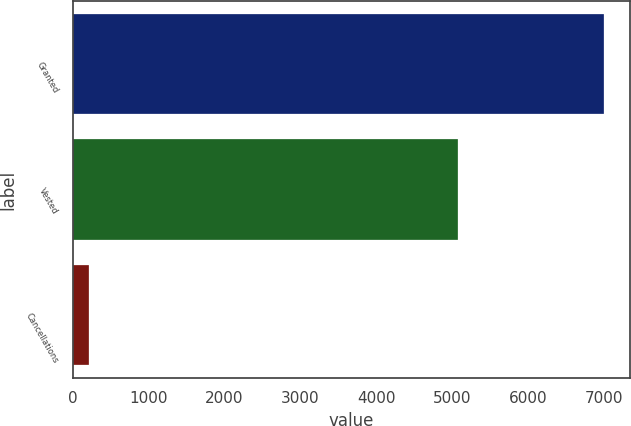Convert chart to OTSL. <chart><loc_0><loc_0><loc_500><loc_500><bar_chart><fcel>Granted<fcel>Vested<fcel>Cancellations<nl><fcel>6995<fcel>5079<fcel>221<nl></chart> 